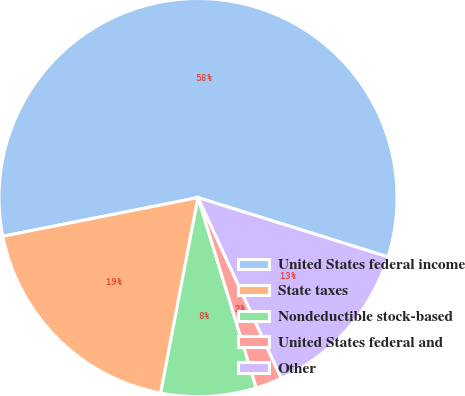Convert chart to OTSL. <chart><loc_0><loc_0><loc_500><loc_500><pie_chart><fcel>United States federal income<fcel>State taxes<fcel>Nondeductible stock-based<fcel>United States federal and<fcel>Other<nl><fcel>57.93%<fcel>18.88%<fcel>7.73%<fcel>2.15%<fcel>13.31%<nl></chart> 